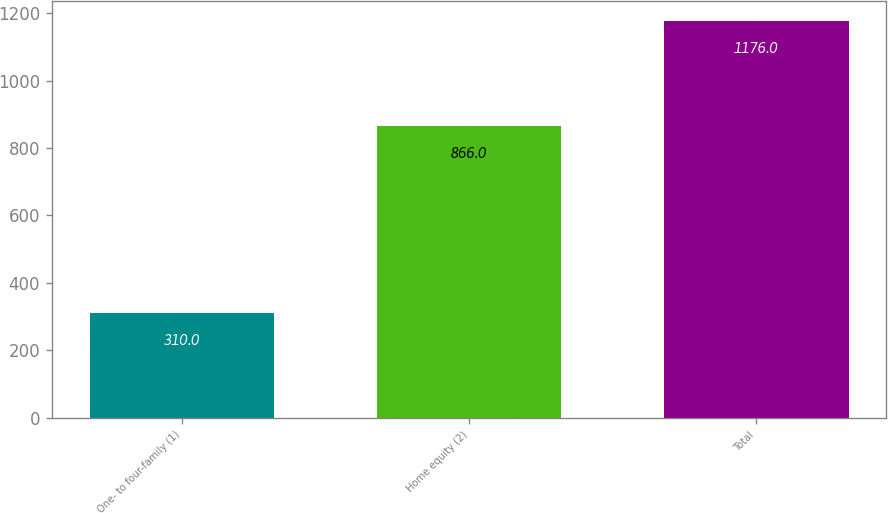Convert chart. <chart><loc_0><loc_0><loc_500><loc_500><bar_chart><fcel>One- to four-family (1)<fcel>Home equity (2)<fcel>Total<nl><fcel>310<fcel>866<fcel>1176<nl></chart> 